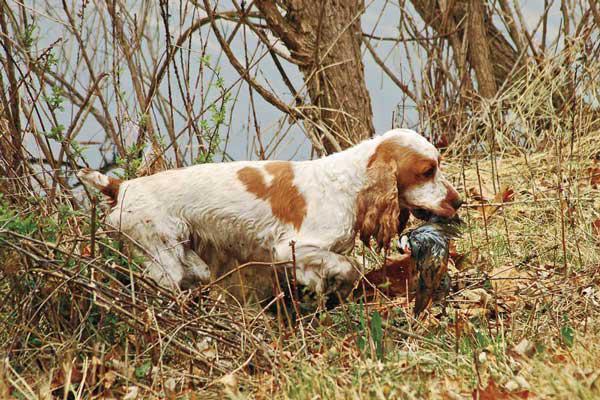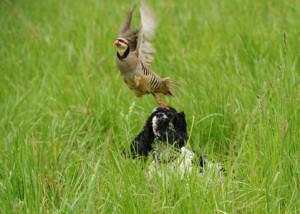The first image is the image on the left, the second image is the image on the right. Given the left and right images, does the statement "Each image shows a spaniel carrying a bird in its mouth across the ground." hold true? Answer yes or no. No. The first image is the image on the left, the second image is the image on the right. Analyze the images presented: Is the assertion "Each image shows a dog on dry land carrying a bird in its mouth." valid? Answer yes or no. No. 